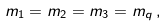Convert formula to latex. <formula><loc_0><loc_0><loc_500><loc_500>m _ { 1 } = m _ { 2 } = m _ { 3 } = m _ { q } \, ,</formula> 